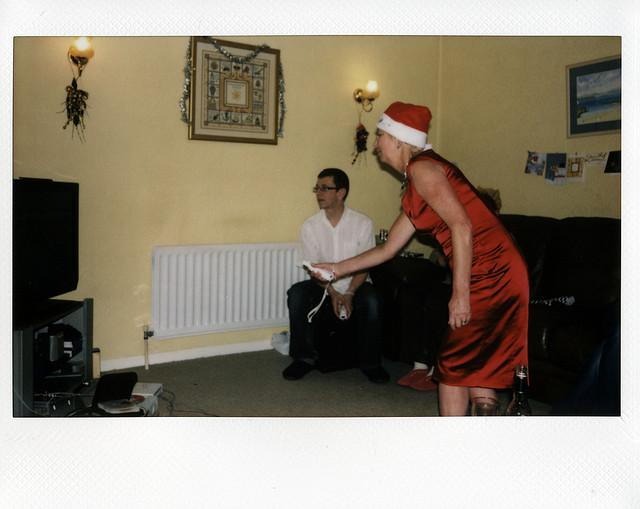What gift did the woman seen here get for Christmas? wii 